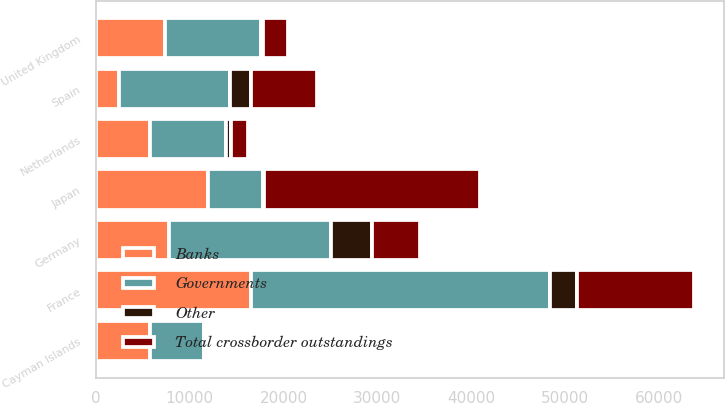<chart> <loc_0><loc_0><loc_500><loc_500><stacked_bar_chart><ecel><fcel>Cayman Islands<fcel>Japan<fcel>France<fcel>Germany<fcel>Spain<fcel>United Kingdom<fcel>Netherlands<nl><fcel>Total crossborder outstandings<fcel>12<fcel>23026<fcel>12427<fcel>5148<fcel>7002<fcel>2688<fcel>1785<nl><fcel>Other<fcel>1<fcel>123<fcel>2871<fcel>4336<fcel>2281<fcel>217<fcel>540<nl><fcel>Banks<fcel>5786<fcel>11981<fcel>16567<fcel>7793<fcel>2491<fcel>7321<fcel>5786<nl><fcel>Governments<fcel>5786<fcel>5786<fcel>31865<fcel>17277<fcel>11774<fcel>10226<fcel>8111<nl></chart> 